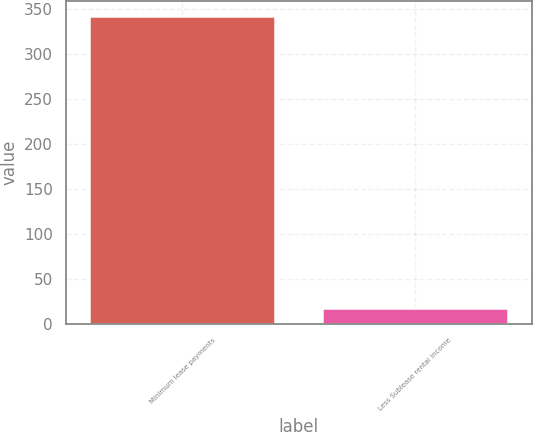Convert chart. <chart><loc_0><loc_0><loc_500><loc_500><bar_chart><fcel>Minimum lease payments<fcel>Less Sublease rental income<nl><fcel>342<fcel>18<nl></chart> 